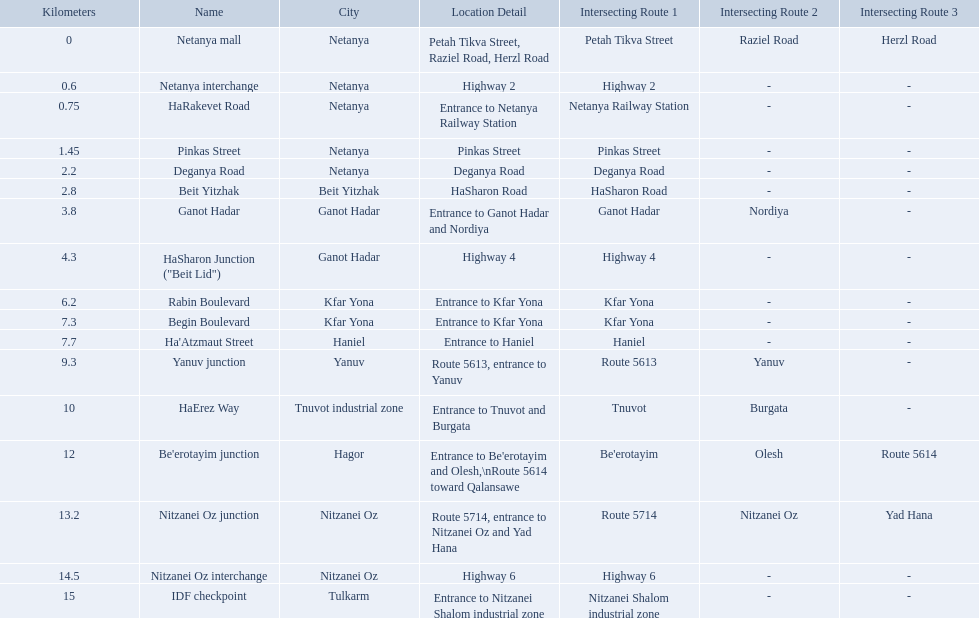What is the intersecting route of rabin boulevard? Entrance to Kfar Yona. Which portion has this intersecting route? Begin Boulevard. What are all the names? Netanya mall, Netanya interchange, HaRakevet Road, Pinkas Street, Deganya Road, Beit Yitzhak, Ganot Hadar, HaSharon Junction ("Beit Lid"), Rabin Boulevard, Begin Boulevard, Ha'Atzmaut Street, Yanuv junction, HaErez Way, Be'erotayim junction, Nitzanei Oz junction, Nitzanei Oz interchange, IDF checkpoint. Where do they intersect? Petah Tikva Street, Raziel Road, Herzl Road, Highway 2, Entrance to Netanya Railway Station, Pinkas Street, Deganya Road, HaSharon Road, Entrance to Ganot Hadar and Nordiya, Highway 4, Entrance to Kfar Yona, Entrance to Kfar Yona, Entrance to Haniel, Route 5613, entrance to Yanuv, Entrance to Tnuvot and Burgata, Entrance to Be'erotayim and Olesh,\nRoute 5614 toward Qalansawe, Route 5714, entrance to Nitzanei Oz and Yad Hana, Highway 6, Entrance to Nitzanei Shalom industrial zone. And which shares an intersection with rabin boulevard? Begin Boulevard. 